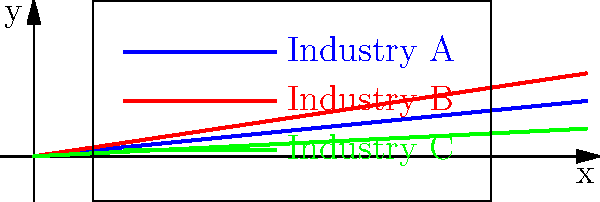The polar coordinate graph shows the economic growth patterns of three industries over time, represented as spiral curves. Industry A (blue) grows at a rate of 10% per unit time, Industry B (red) at 15% per unit time, and Industry C (green) at 5% per unit time. If the government wants to invest in the industry with the highest absolute growth after 5 time units, which industry should they choose? To solve this problem, we need to calculate the absolute growth for each industry after 5 time units:

1. For Industry A (blue):
   Growth rate = 10% = 0.1
   Radius after 5 time units = $0.1 * 5 = 0.5$

2. For Industry B (red):
   Growth rate = 15% = 0.15
   Radius after 5 time units = $0.15 * 5 = 0.75$

3. For Industry C (green):
   Growth rate = 5% = 0.05
   Radius after 5 time units = $0.05 * 5 = 0.25$

The radius in the polar coordinate system represents the absolute growth of each industry. After 5 time units, Industry B has the largest radius (0.75), indicating the highest absolute growth.

Therefore, if the government wants to invest in the industry with the highest absolute growth after 5 time units, they should choose Industry B.
Answer: Industry B 